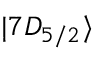<formula> <loc_0><loc_0><loc_500><loc_500>| 7 D _ { 5 / 2 } \rangle</formula> 